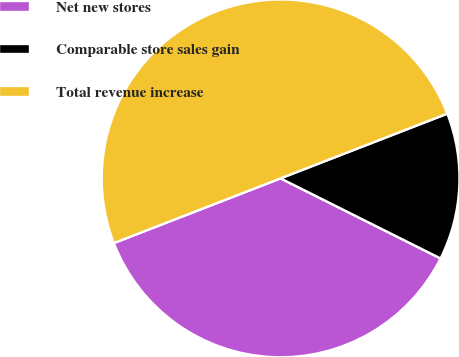Convert chart to OTSL. <chart><loc_0><loc_0><loc_500><loc_500><pie_chart><fcel>Net new stores<fcel>Comparable store sales gain<fcel>Total revenue increase<nl><fcel>36.72%<fcel>13.28%<fcel>50.0%<nl></chart> 